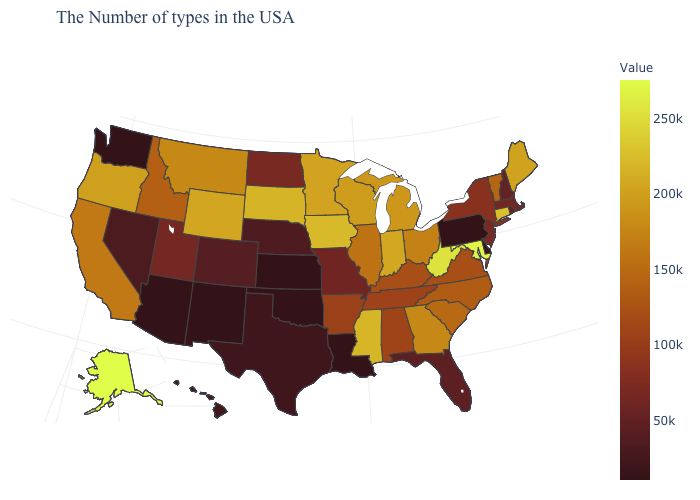Among the states that border Mississippi , which have the highest value?
Give a very brief answer. Alabama. Which states have the lowest value in the USA?
Concise answer only. Delaware, Pennsylvania, Louisiana, Kansas, Oklahoma, New Mexico, Arizona, Washington. Does Oklahoma have the highest value in the South?
Answer briefly. No. Does Ohio have a lower value than Texas?
Give a very brief answer. No. Which states have the highest value in the USA?
Answer briefly. Alaska. Does Vermont have the lowest value in the Northeast?
Write a very short answer. No. 